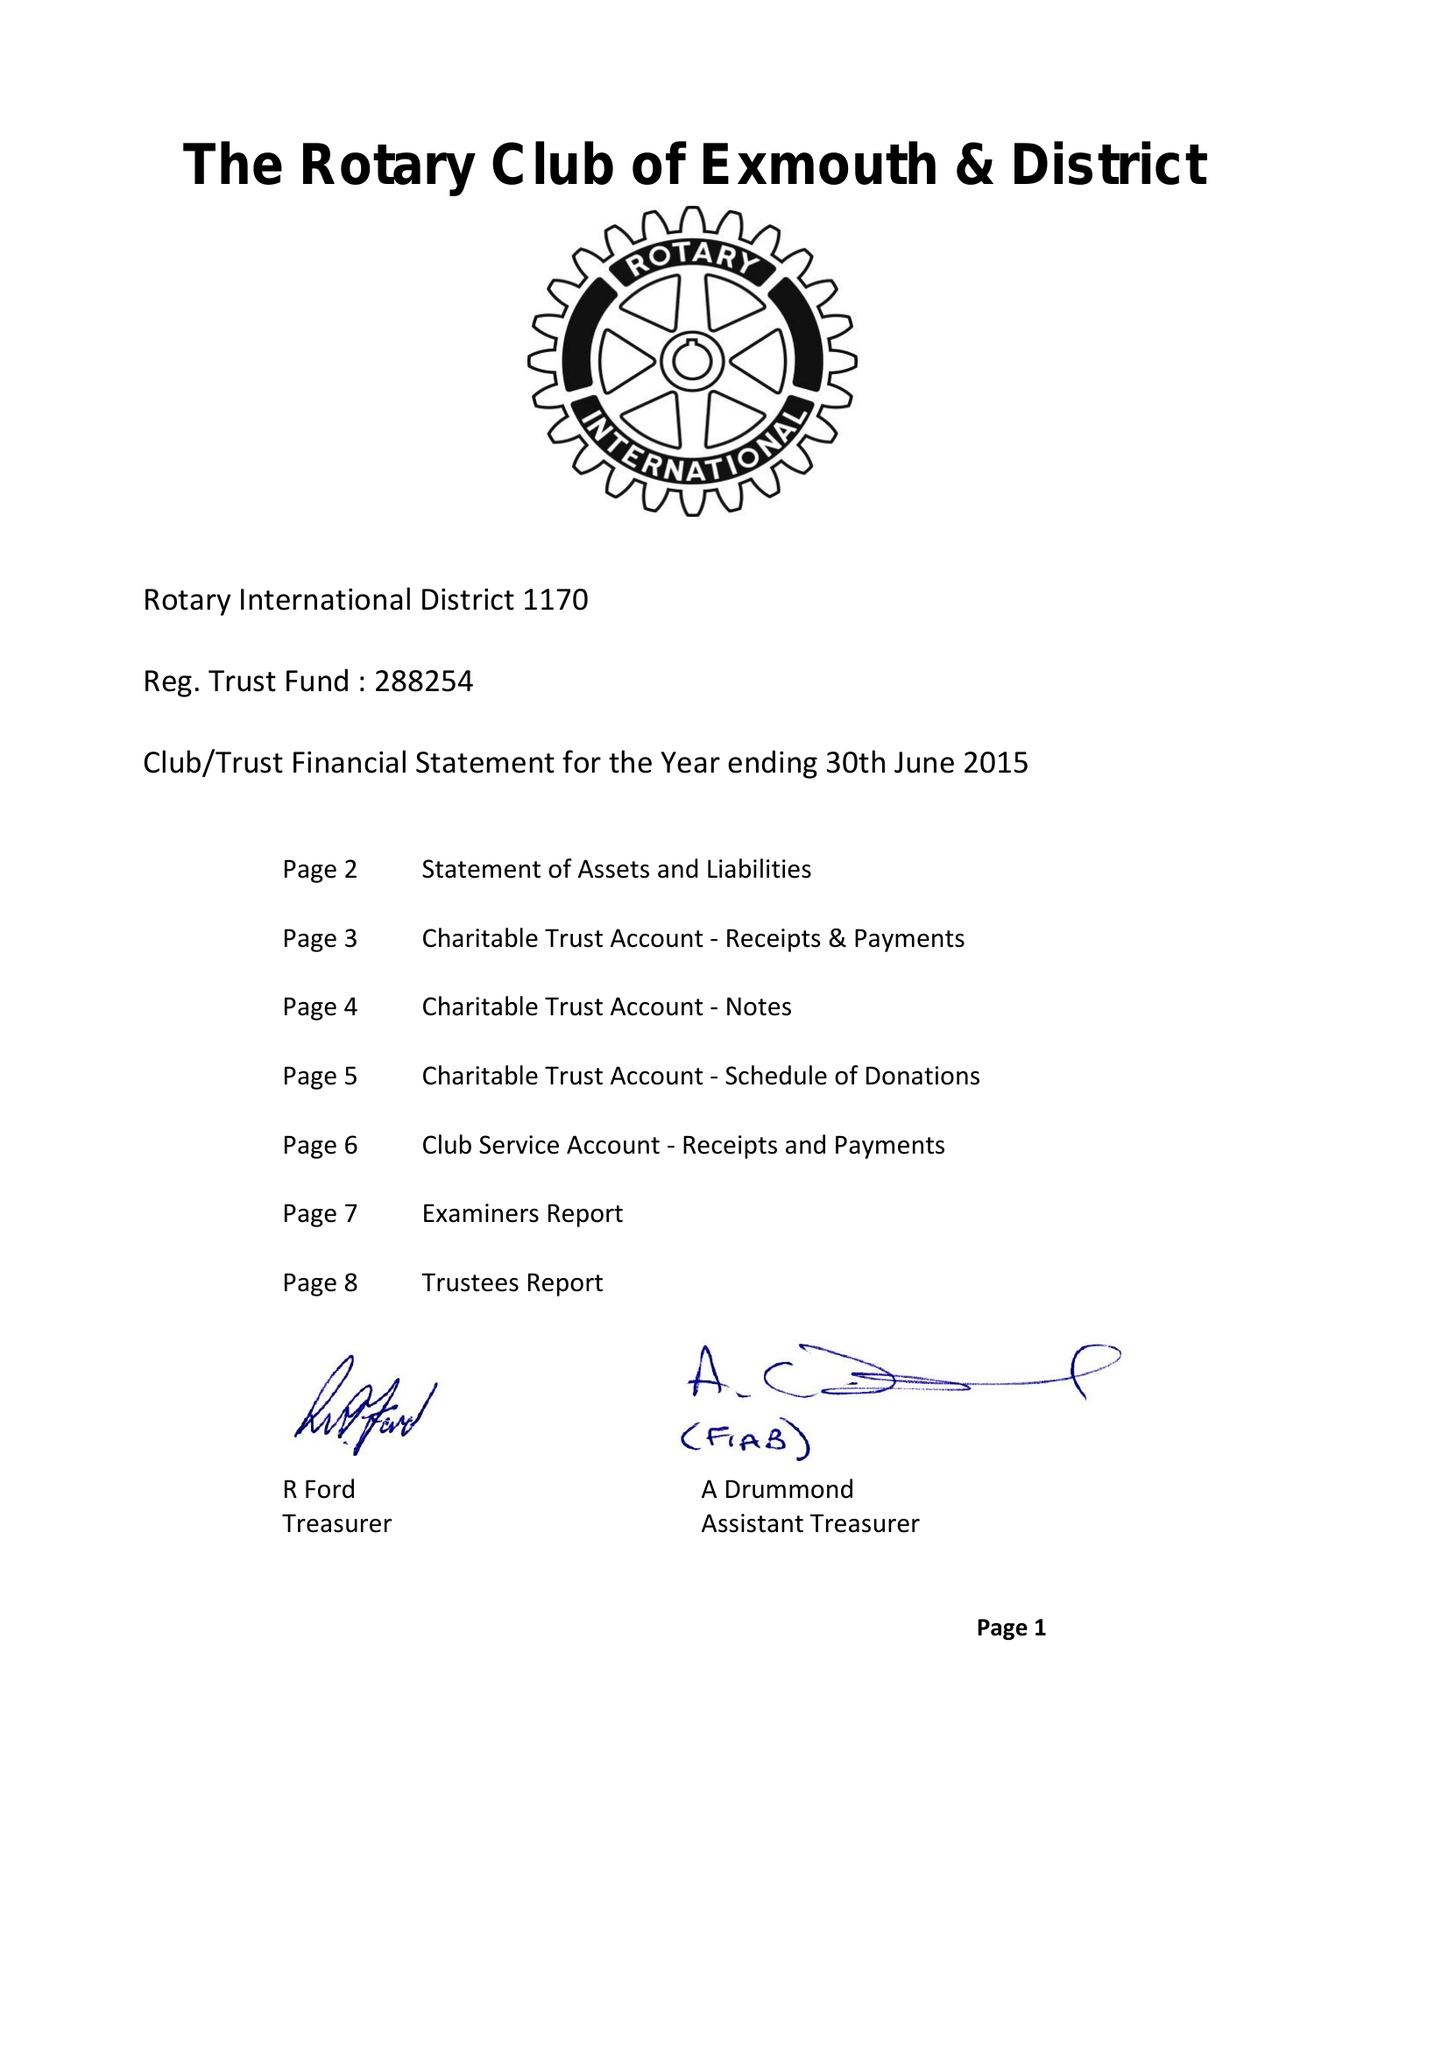What is the value for the spending_annually_in_british_pounds?
Answer the question using a single word or phrase. 43376.00 